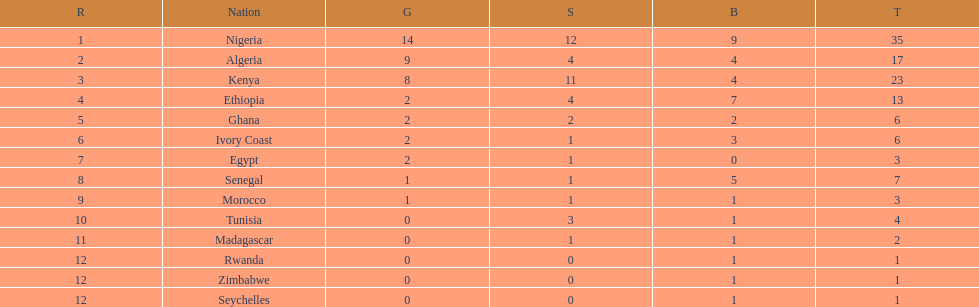Which country had the least bronze medals? Egypt. 